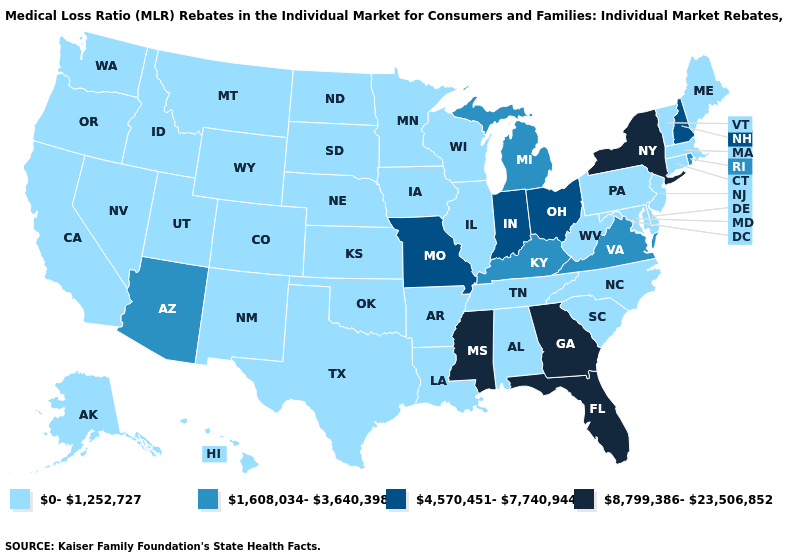How many symbols are there in the legend?
Concise answer only. 4. Name the states that have a value in the range 1,608,034-3,640,398?
Short answer required. Arizona, Kentucky, Michigan, Rhode Island, Virginia. Which states have the highest value in the USA?
Keep it brief. Florida, Georgia, Mississippi, New York. Name the states that have a value in the range 1,608,034-3,640,398?
Quick response, please. Arizona, Kentucky, Michigan, Rhode Island, Virginia. What is the value of Washington?
Be succinct. 0-1,252,727. Name the states that have a value in the range 1,608,034-3,640,398?
Concise answer only. Arizona, Kentucky, Michigan, Rhode Island, Virginia. What is the value of Delaware?
Give a very brief answer. 0-1,252,727. What is the value of Maine?
Short answer required. 0-1,252,727. What is the value of New York?
Be succinct. 8,799,386-23,506,852. What is the highest value in the USA?
Quick response, please. 8,799,386-23,506,852. Which states have the highest value in the USA?
Short answer required. Florida, Georgia, Mississippi, New York. Among the states that border Arkansas , which have the lowest value?
Answer briefly. Louisiana, Oklahoma, Tennessee, Texas. What is the value of New Jersey?
Concise answer only. 0-1,252,727. Name the states that have a value in the range 1,608,034-3,640,398?
Write a very short answer. Arizona, Kentucky, Michigan, Rhode Island, Virginia. Name the states that have a value in the range 8,799,386-23,506,852?
Be succinct. Florida, Georgia, Mississippi, New York. 